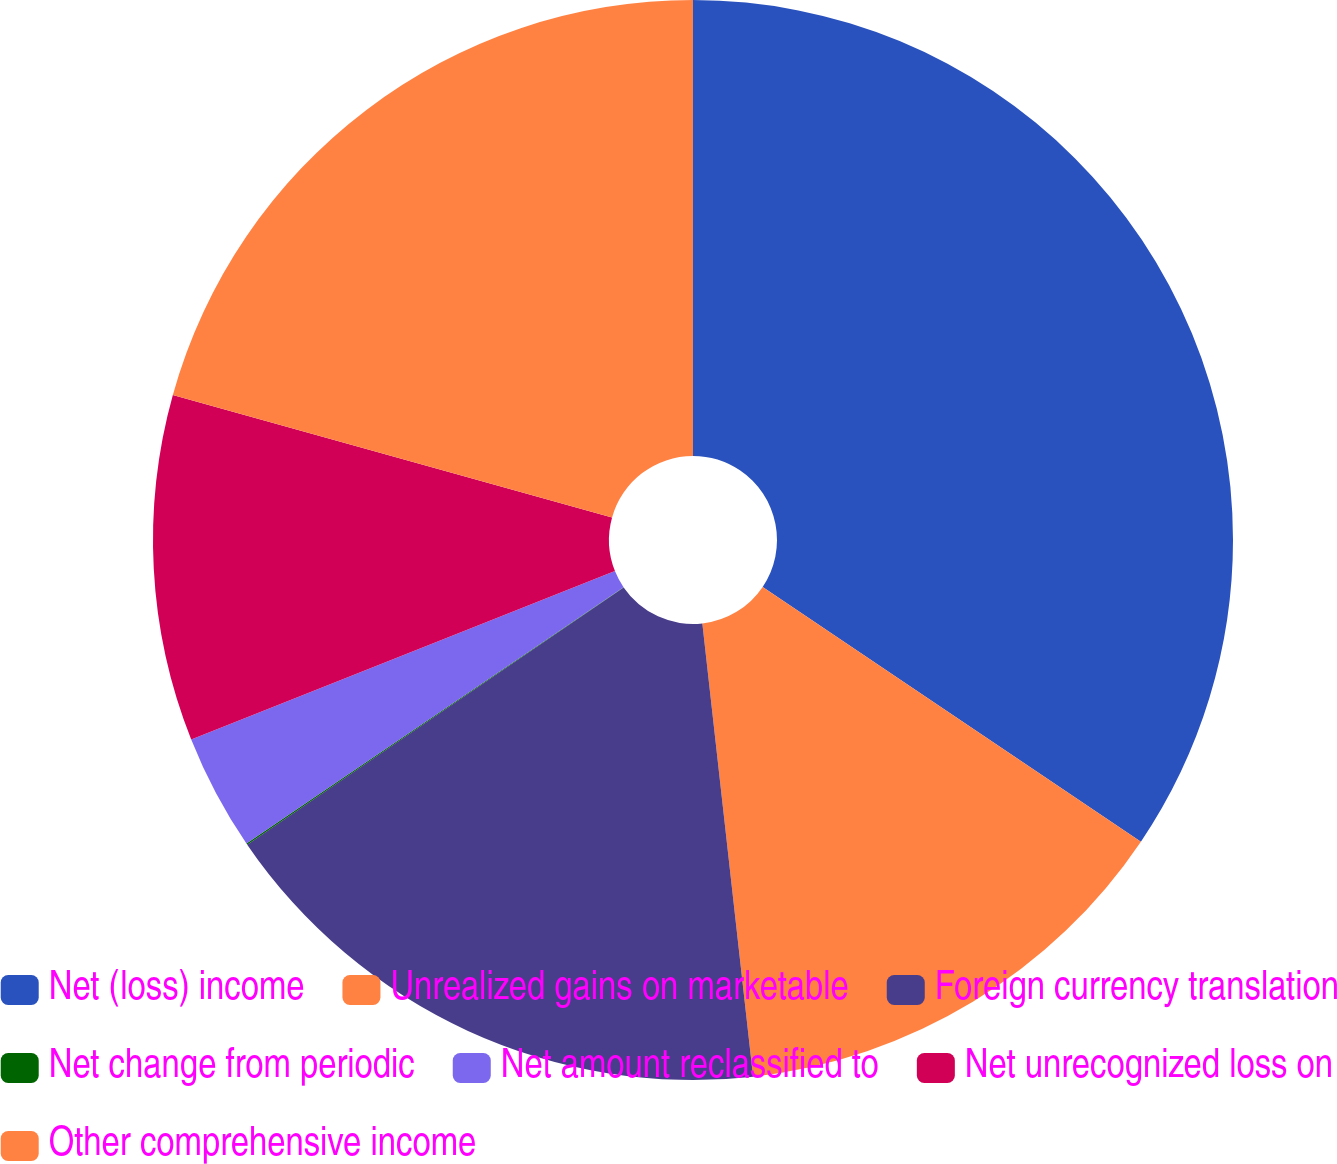Convert chart. <chart><loc_0><loc_0><loc_500><loc_500><pie_chart><fcel>Net (loss) income<fcel>Unrealized gains on marketable<fcel>Foreign currency translation<fcel>Net change from periodic<fcel>Net amount reclassified to<fcel>Net unrecognized loss on<fcel>Other comprehensive income<nl><fcel>34.43%<fcel>13.79%<fcel>17.23%<fcel>0.04%<fcel>3.48%<fcel>10.35%<fcel>20.67%<nl></chart> 